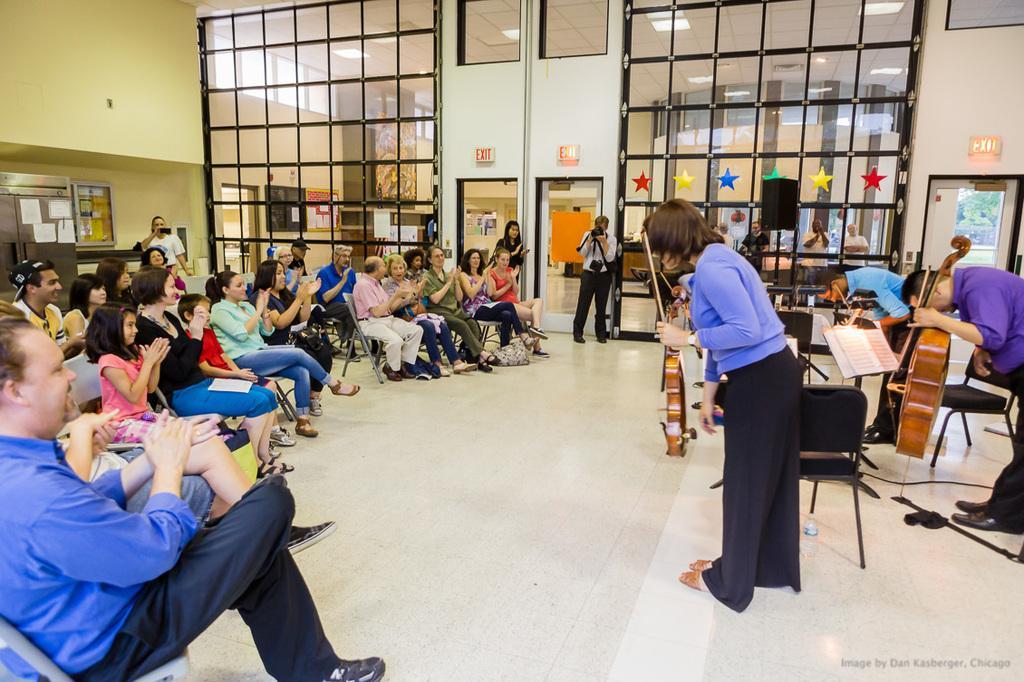Please provide a concise description of this image. On the left side there are many people sitting on chairs. On the right side there are many people holding musical instruments. There are chairs. In the back there is a glass wall and doors. Also there are exit boards on the wall. On the left side there is a wall. Near to that there is a cupboard. 